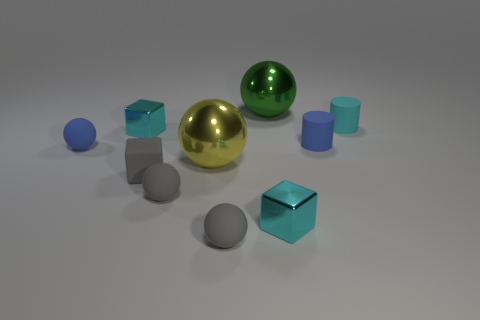Are there any blue objects of the same shape as the large green shiny object?
Offer a terse response. Yes. What is the shape of the tiny gray thing that is to the right of the yellow metallic object?
Your response must be concise. Sphere. How many large green cubes are there?
Provide a succinct answer. 0. What color is the other small cylinder that is made of the same material as the small cyan cylinder?
Offer a very short reply. Blue. How many big things are green objects or gray rubber objects?
Your answer should be compact. 1. How many tiny rubber things are behind the yellow sphere?
Offer a very short reply. 3. What is the color of the other metal thing that is the same shape as the big yellow metal object?
Give a very brief answer. Green. What number of matte objects are either gray balls or tiny balls?
Ensure brevity in your answer.  3. There is a tiny cyan metallic object in front of the tiny sphere behind the large yellow thing; are there any small cubes that are on the left side of it?
Offer a very short reply. Yes. The rubber cube has what color?
Your answer should be compact. Gray. 